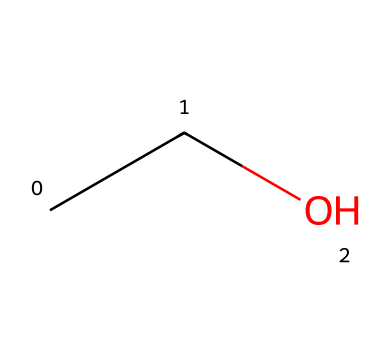What is the name of this chemical? This chemical's SMILES representation "CCO" corresponds to ethanol, which is commonly found in craft beer.
Answer: ethanol How many carbon atoms are present in this chemical? In the SMILES "CCO," there are two carbon atoms represented by the two "C" letters.
Answer: 2 What type of alcohol is represented by this structure? The SMILES "CCO" indicates that it is a primary alcohol, specifically ethanol, due to the presence of a hydroxyl group (-OH) attached to a carbon chain.
Answer: primary How many hydrogen atoms are in this chemical? From the structure "CCO," each carbon atom typically bonds with enough hydrogen atoms to satisfy carbon's tetravalency. The formula is C2H6O, which shows there are six hydrogen atoms.
Answer: 6 What functional group does this chemical contain? The hydroxyl group (-OH) is identified in the SMILES "CCO," which is characteristic of alcohols, indicating its functional group.
Answer: hydroxyl What is the state of this chemical at room temperature? Ethanol, represented by the structure "CCO," is a liquid at room temperature, commonly found in beverages like craft beer.
Answer: liquid 